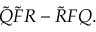Convert formula to latex. <formula><loc_0><loc_0><loc_500><loc_500>\tilde { Q } \tilde { F } R - \tilde { R } F Q .</formula> 